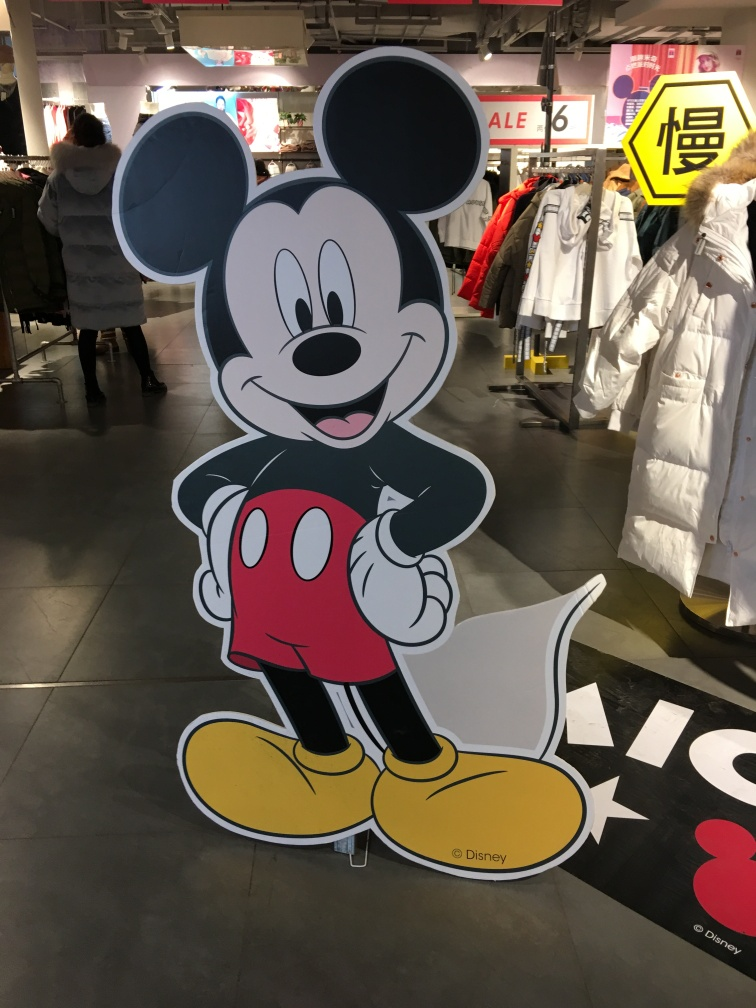Can you describe the expression and body language of the character? The character has a bright and welcoming expression, with wide open eyes and a broad smile. Its body language, with one hand up in a wave, suggests an inviting and friendly demeanor, typical of this character's design to convey positivity. 